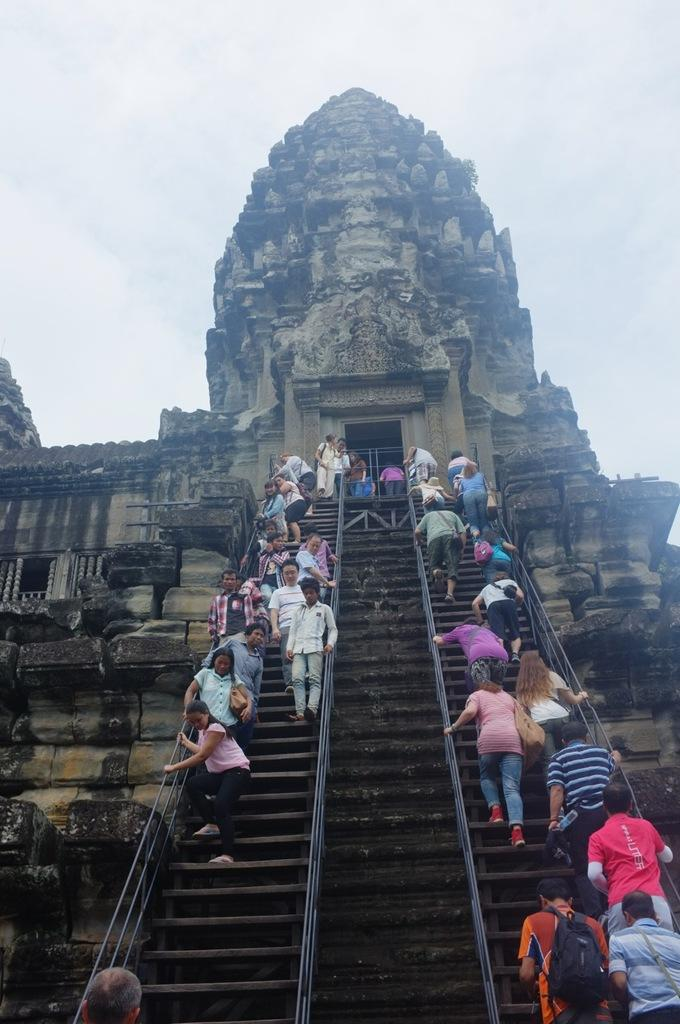What are the people in the image doing? The people in the image are standing on the stairs. What structure is visible in the image? There is a building in the image. What is the condition of the sky in the image? The sky is clear in the image. What type of maid can be seen cleaning the fang in the image? There is no maid or fang present in the image. 